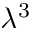<formula> <loc_0><loc_0><loc_500><loc_500>\lambda ^ { 3 }</formula> 